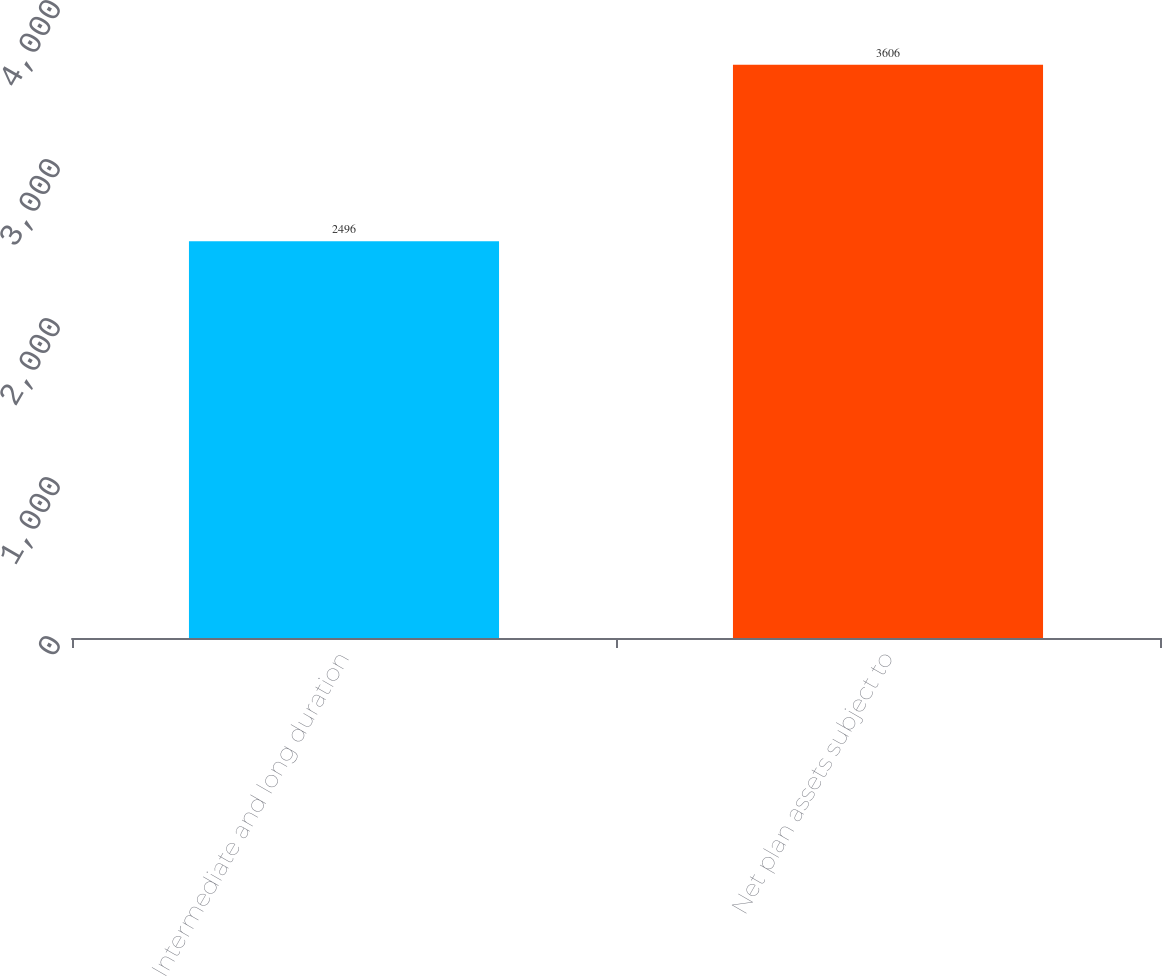Convert chart. <chart><loc_0><loc_0><loc_500><loc_500><bar_chart><fcel>Intermediate and long duration<fcel>Net plan assets subject to<nl><fcel>2496<fcel>3606<nl></chart> 